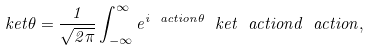<formula> <loc_0><loc_0><loc_500><loc_500>\ k e t { \theta } = \frac { 1 } { \sqrt { 2 \pi } } \int _ { - \infty } ^ { \infty } e ^ { i \ a c t i o n \theta } \ k e t { \ a c t i o n } d \ a c t i o n ,</formula> 